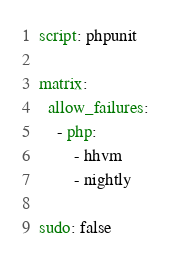Convert code to text. <code><loc_0><loc_0><loc_500><loc_500><_YAML_>
script: phpunit

matrix:
  allow_failures:
    - php:
        - hhvm
        - nightly

sudo: false
</code> 